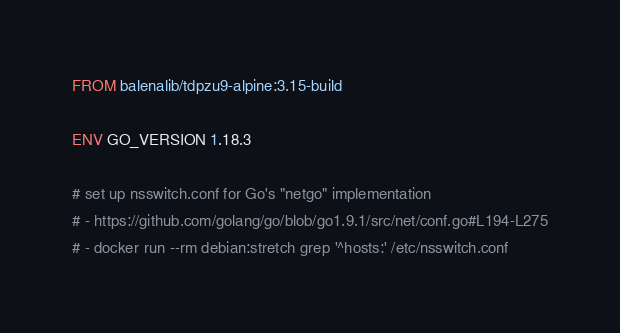Convert code to text. <code><loc_0><loc_0><loc_500><loc_500><_Dockerfile_>FROM balenalib/tdpzu9-alpine:3.15-build

ENV GO_VERSION 1.18.3

# set up nsswitch.conf for Go's "netgo" implementation
# - https://github.com/golang/go/blob/go1.9.1/src/net/conf.go#L194-L275
# - docker run --rm debian:stretch grep '^hosts:' /etc/nsswitch.conf</code> 